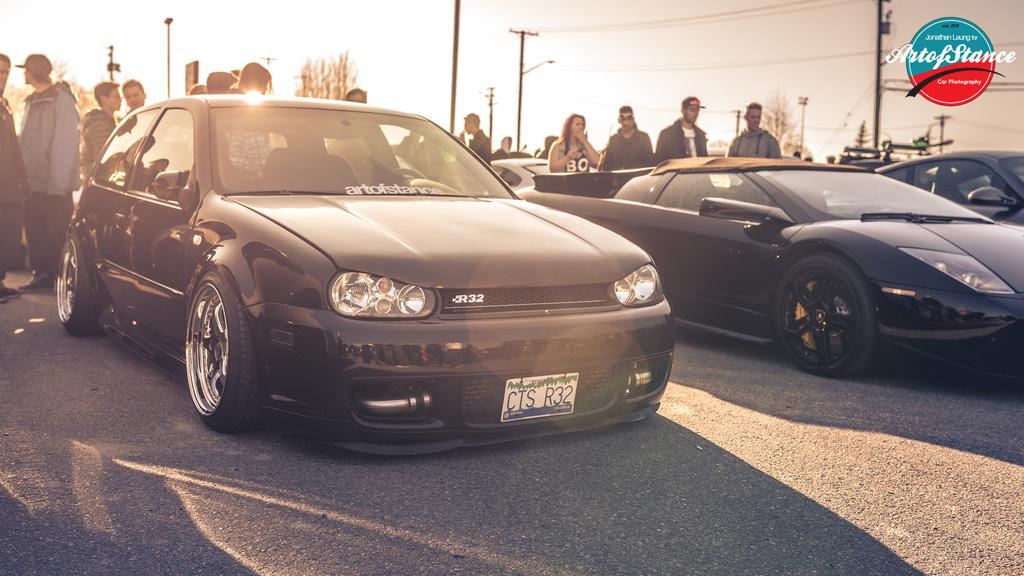What type of vehicles can be seen in the image? There are cars in the image. Are there any people present in the image? Yes, there are people in the image. What structures can be seen in the image? There are poles and electric poles in the image. What type of natural elements are visible in the image? There are trees in the image. What is visible in the background of the image? The sky is visible in the image. What type of picture is hanging on the wall in the image? There is no mention of a picture hanging on the wall in the image; the facts provided only mention cars, people, poles, electric poles, trees, and the sky. What song is being played in the background of the image? There is no mention of any music or sound in the image; the facts provided only mention visual elements. 